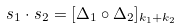<formula> <loc_0><loc_0><loc_500><loc_500>s _ { 1 } \cdot s _ { 2 } = [ \Delta _ { 1 } \circ \Delta _ { 2 } ] _ { k _ { 1 } + k _ { 2 } }</formula> 